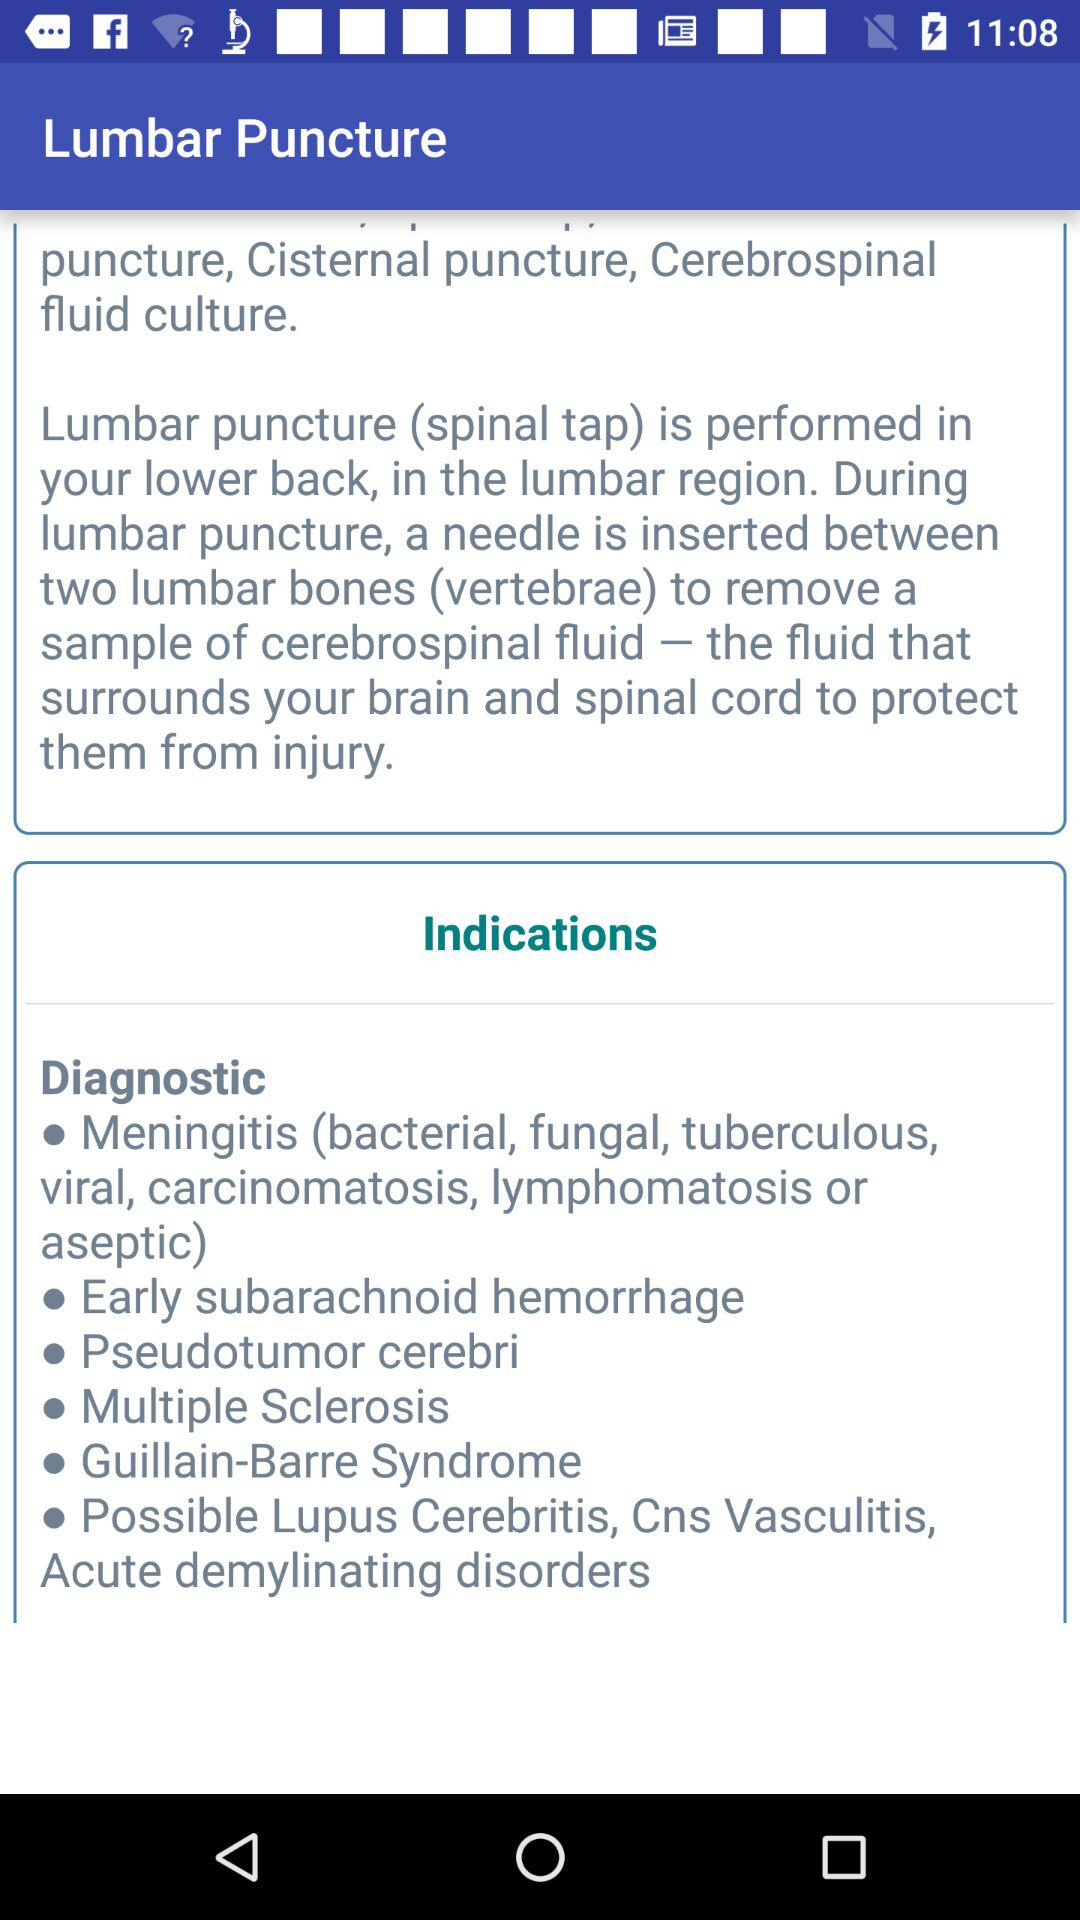Between how many bones is the needle inserted during a lumbar puncture? The needle is inserted between two bones during a lumbar puncture. 